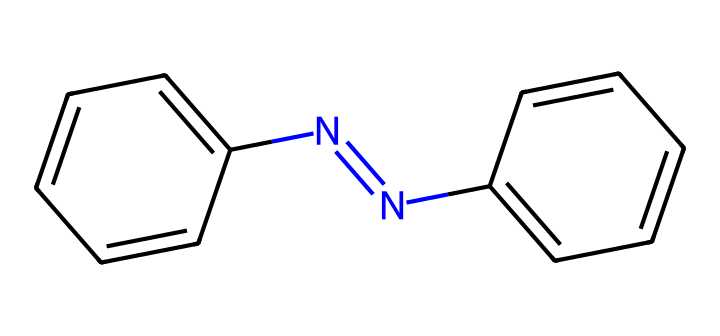What is the molecular formula of azobenzene? To determine the molecular formula, count the number of each type of atom in the SMILES representation. The structure has 12 carbon (C) atoms, 10 hydrogen (H) atoms, and 2 nitrogen (N) atoms. Hence, the formula is C12H10N2.
Answer: C12H10N2 How many double bonds are present in azobenzene? In the provided chemical structure, analyze the connections: there are two nitrogen atoms connected to each other via a double bond and each aromatic ring has alternating double bonds. Therefore, there are three double bonds in total.
Answer: 3 What type of compound is azobenzene? Azobenzene is classified chemically as an azo compound, which is characterized by the presence of a nitrogen-nitrogen double bond (N=N).
Answer: azo compound What property allows azobenzene to be photoreactive? Azobenzene's photoisomerization property is due to its ability to switch between trans and cis configurations upon exposure to light, specifically UV light. This unique feature makes it responsive to light.
Answer: photoisomerization Which functional group distinguishes azobenzene? The distinctive functional group is the azo group (-N=N-), which is a characteristic of azo compounds. This linkage is crucial for its light responsiveness.
Answer: azo group How many aromatic rings are present in azobenzene? The SMILES representation indicates two phenyl (aromatic) rings attached to the azo group, which defines the structure of azobenzene. Therefore, there are two aromatic rings.
Answer: 2 What is the significance of the cis-trans isomerism in azobenzene? Cis-trans isomerism is significant because it allows azobenzene to change structure in response to light, affecting its interactions with materials and thus its applications in light-responsive textiles.
Answer: structural change 